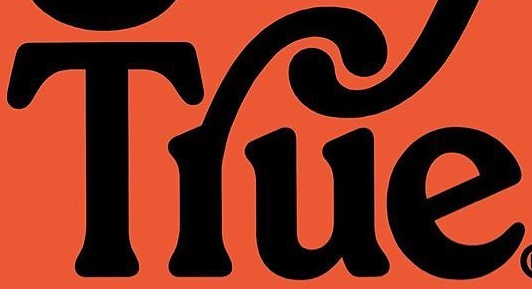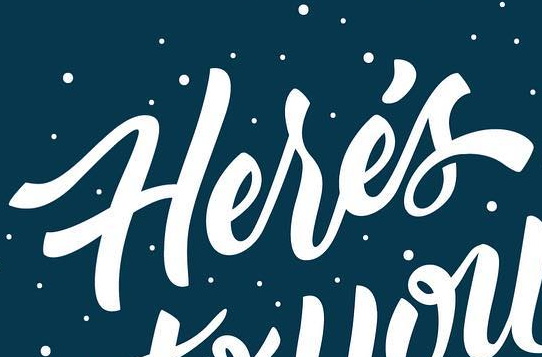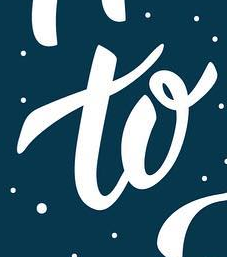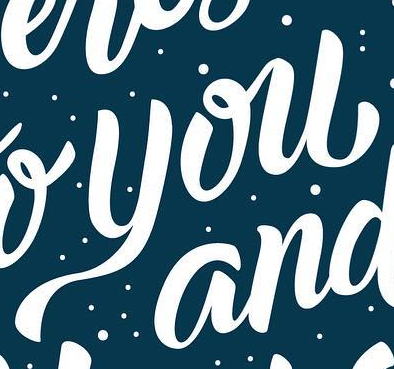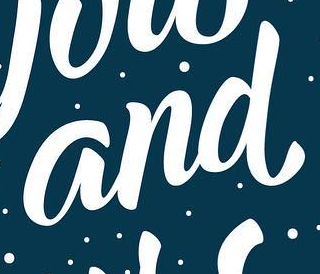What words are shown in these images in order, separated by a semicolon? Tlue; Herés; to; you; and 